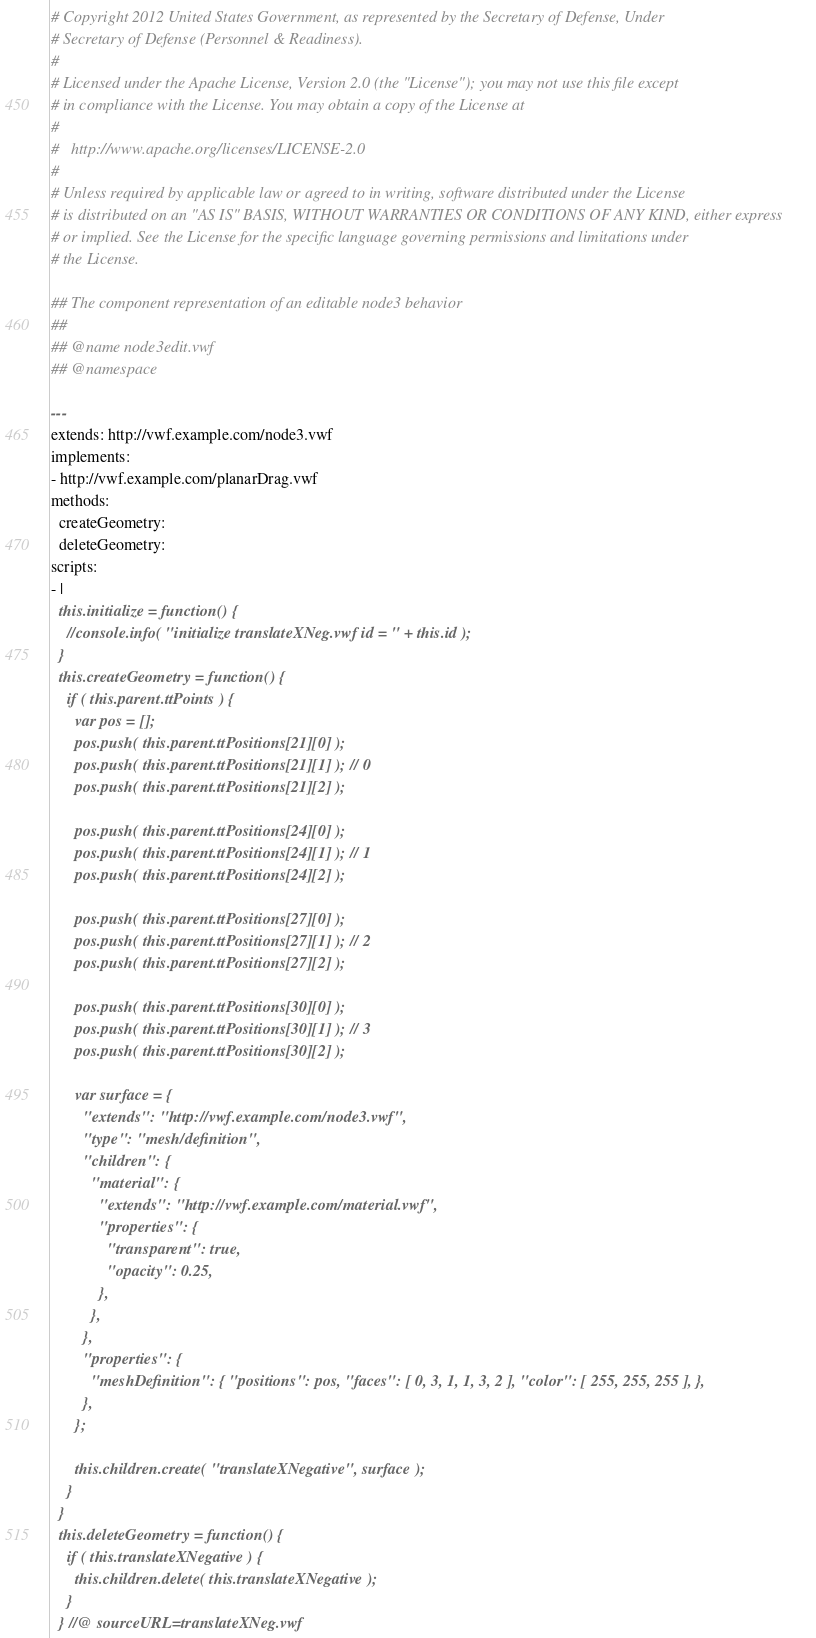Convert code to text. <code><loc_0><loc_0><loc_500><loc_500><_YAML_># Copyright 2012 United States Government, as represented by the Secretary of Defense, Under
# Secretary of Defense (Personnel & Readiness).
# 
# Licensed under the Apache License, Version 2.0 (the "License"); you may not use this file except
# in compliance with the License. You may obtain a copy of the License at
# 
#   http://www.apache.org/licenses/LICENSE-2.0
# 
# Unless required by applicable law or agreed to in writing, software distributed under the License
# is distributed on an "AS IS" BASIS, WITHOUT WARRANTIES OR CONDITIONS OF ANY KIND, either express
# or implied. See the License for the specific language governing permissions and limitations under
# the License.

## The component representation of an editable node3 behavior
## 
## @name node3edit.vwf
## @namespace

--- 
extends: http://vwf.example.com/node3.vwf
implements:
- http://vwf.example.com/planarDrag.vwf
methods:
  createGeometry:
  deleteGeometry:
scripts:
- |
  this.initialize = function() {
    //console.info( "initialize translateXNeg.vwf id = " + this.id );
  }
  this.createGeometry = function() {
    if ( this.parent.ttPoints ) {
      var pos = [];
      pos.push( this.parent.ttPositions[21][0] );
      pos.push( this.parent.ttPositions[21][1] ); // 0       
      pos.push( this.parent.ttPositions[21][2] );

      pos.push( this.parent.ttPositions[24][0] );
      pos.push( this.parent.ttPositions[24][1] ); // 1       
      pos.push( this.parent.ttPositions[24][2] );
      
      pos.push( this.parent.ttPositions[27][0] );
      pos.push( this.parent.ttPositions[27][1] ); // 2       
      pos.push( this.parent.ttPositions[27][2] );
      
      pos.push( this.parent.ttPositions[30][0] );
      pos.push( this.parent.ttPositions[30][1] ); // 3   
      pos.push( this.parent.ttPositions[30][2] );        
    
      var surface = {
        "extends": "http://vwf.example.com/node3.vwf",
        "type": "mesh/definition",
        "children": {
          "material": {
            "extends": "http://vwf.example.com/material.vwf",
            "properties": {
              "transparent": true,
              "opacity": 0.25, 
            },
          },
        },
        "properties": { 
          "meshDefinition": { "positions": pos, "faces": [ 0, 3, 1, 1, 3, 2 ], "color": [ 255, 255, 255 ], },
        },
      };
      
      this.children.create( "translateXNegative", surface );
    }    
  } 
  this.deleteGeometry = function() {
    if ( this.translateXNegative ) {
      this.children.delete( this.translateXNegative );
    }
  } //@ sourceURL=translateXNeg.vwf
</code> 